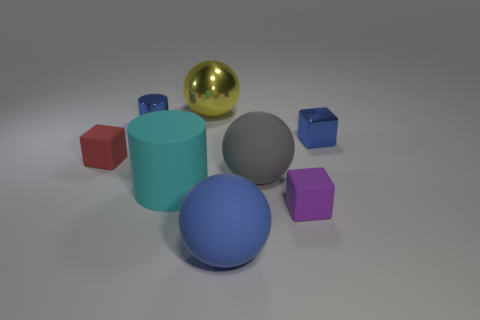What number of tiny things are either blue metal cylinders or red shiny spheres?
Provide a short and direct response. 1. What is the material of the tiny cylinder?
Your answer should be very brief. Metal. What is the material of the sphere that is both in front of the metallic cylinder and behind the small purple matte block?
Provide a succinct answer. Rubber. There is a metallic block; is it the same color as the tiny shiny thing to the left of the big blue matte ball?
Offer a terse response. Yes. What is the material of the yellow thing that is the same size as the blue sphere?
Keep it short and to the point. Metal. Are there any spheres made of the same material as the small red block?
Your answer should be compact. Yes. How many big purple things are there?
Make the answer very short. 0. Does the gray thing have the same material as the tiny blue thing left of the yellow ball?
Offer a very short reply. No. There is a block that is the same color as the small cylinder; what is it made of?
Provide a succinct answer. Metal. What number of small metallic blocks are the same color as the small metallic cylinder?
Provide a succinct answer. 1. 